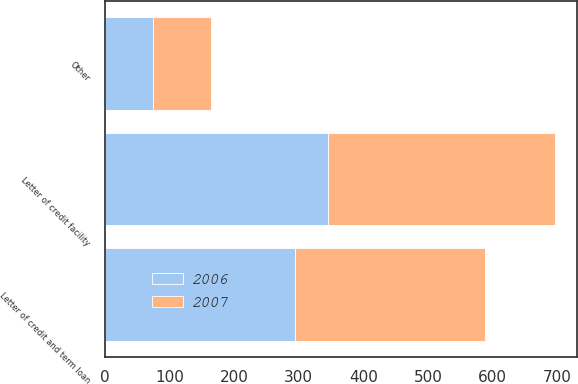Convert chart. <chart><loc_0><loc_0><loc_500><loc_500><stacked_bar_chart><ecel><fcel>Letter of credit facility<fcel>Letter of credit and term loan<fcel>Other<nl><fcel>2007<fcel>350<fcel>294<fcel>90<nl><fcel>2006<fcel>346<fcel>295<fcel>75<nl></chart> 